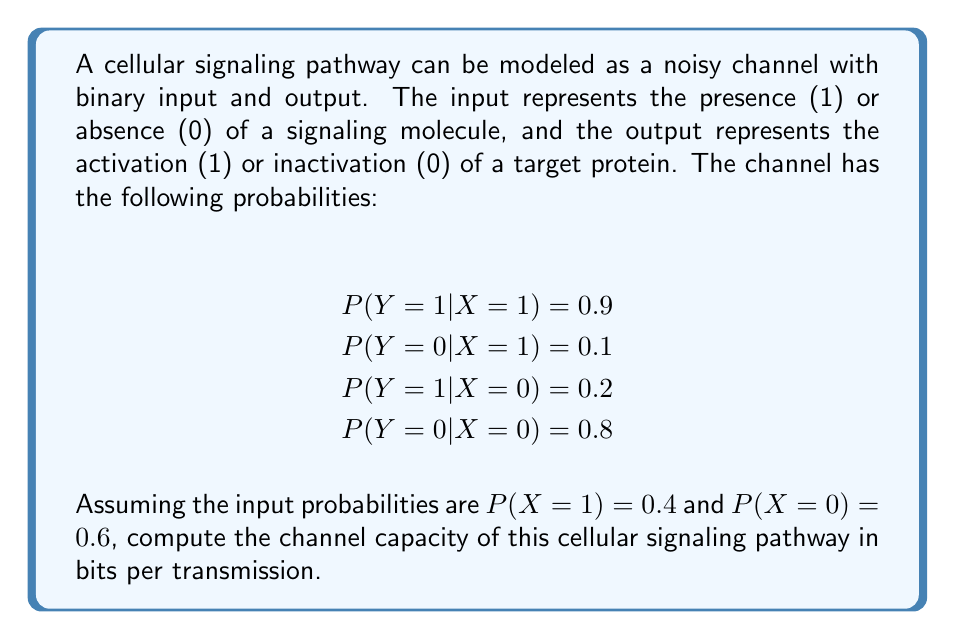Could you help me with this problem? To compute the channel capacity, we need to follow these steps:

1. Calculate the mutual information $I(X;Y)$ for the given input probabilities.
2. Find the input probabilities that maximize $I(X;Y)$.

Step 1: Calculating $I(X;Y)$ for given input probabilities

The mutual information is given by:

$$I(X;Y) = H(Y) - H(Y|X)$$

Where $H(Y)$ is the entropy of the output, and $H(Y|X)$ is the conditional entropy.

First, let's calculate $P(Y=1)$ and $P(Y=0)$:

$P(Y=1) = P(Y=1|X=1)P(X=1) + P(Y=1|X=0)P(X=0) = 0.9 \cdot 0.4 + 0.2 \cdot 0.6 = 0.48$
$P(Y=0) = 1 - P(Y=1) = 0.52$

Now we can calculate $H(Y)$:

$$H(Y) = -P(Y=1)\log_2P(Y=1) - P(Y=0)\log_2P(Y=0) = -0.48\log_2(0.48) - 0.52\log_2(0.52) = 0.9988$$

Next, we calculate $H(Y|X)$:

$$H(Y|X) = P(X=1)H(Y|X=1) + P(X=0)H(Y|X=0)$$

Where:
$H(Y|X=1) = -0.9\log_2(0.9) - 0.1\log_2(0.1) = 0.4690$
$H(Y|X=0) = -0.2\log_2(0.2) - 0.8\log_2(0.8) = 0.7219$

So, $H(Y|X) = 0.4 \cdot 0.4690 + 0.6 \cdot 0.7219 = 0.6205$

Now we can calculate $I(X;Y)$:

$$I(X;Y) = H(Y) - H(Y|X) = 0.9988 - 0.6205 = 0.3783 \text{ bits}$$

Step 2: Finding the input probabilities that maximize $I(X;Y)$

To find the channel capacity, we need to maximize $I(X;Y)$ over all possible input distributions. This is typically done using numerical optimization methods. However, for a binary symmetric channel, we know that the capacity is achieved when the input probabilities are equal, i.e., $P(X=1) = P(X=0) = 0.5$.

Using these probabilities, we recalculate:

$P(Y=1) = 0.9 \cdot 0.5 + 0.2 \cdot 0.5 = 0.55$
$P(Y=0) = 0.45$

$H(Y) = -0.55\log_2(0.55) - 0.45\log_2(0.45) = 0.9928$

$H(Y|X)$ remains the same: $0.6205$

Therefore, the channel capacity is:

$$C = \max_{P(X)} I(X;Y) = H(Y) - H(Y|X) = 0.9928 - 0.6205 = 0.3723 \text{ bits per transmission}$$
Answer: The channel capacity of the cellular signaling pathway is 0.3723 bits per transmission. 